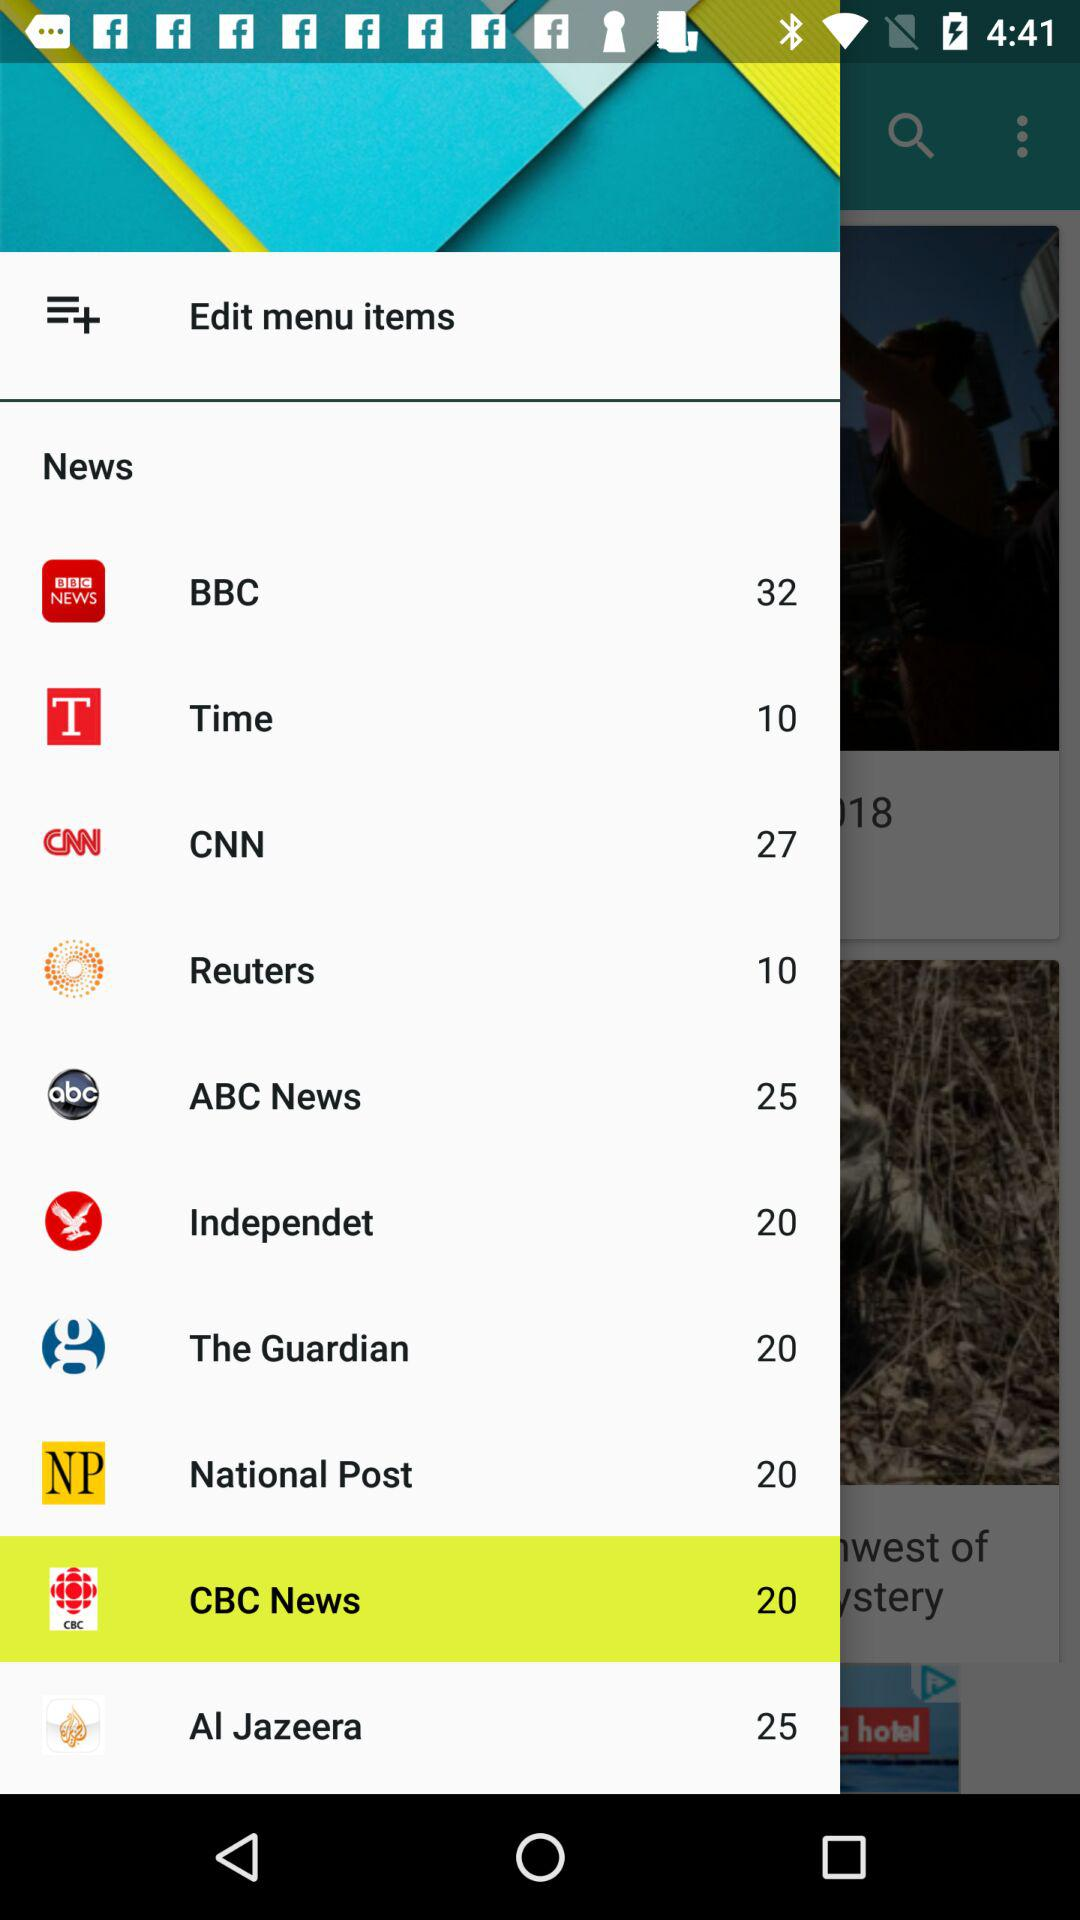How many news stories are there on the BBC? There are 32 news stories. 